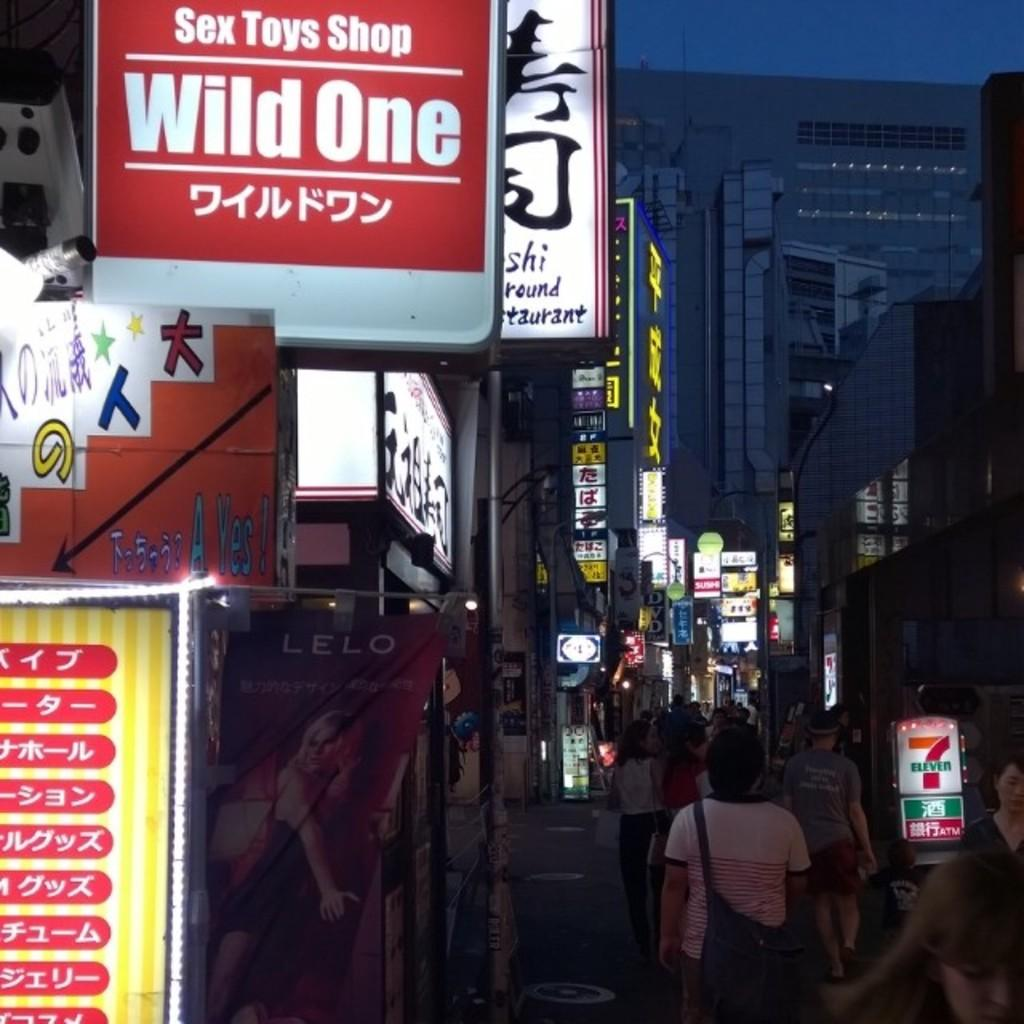Provide a one-sentence caption for the provided image. A city street with people walking and signs above head, one of which reads Toys Shop. 